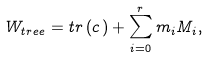Convert formula to latex. <formula><loc_0><loc_0><loc_500><loc_500>W _ { t r e e } = t r \, ( c \, ) + \sum _ { i = 0 } ^ { r } m _ { i } M _ { i } ,</formula> 